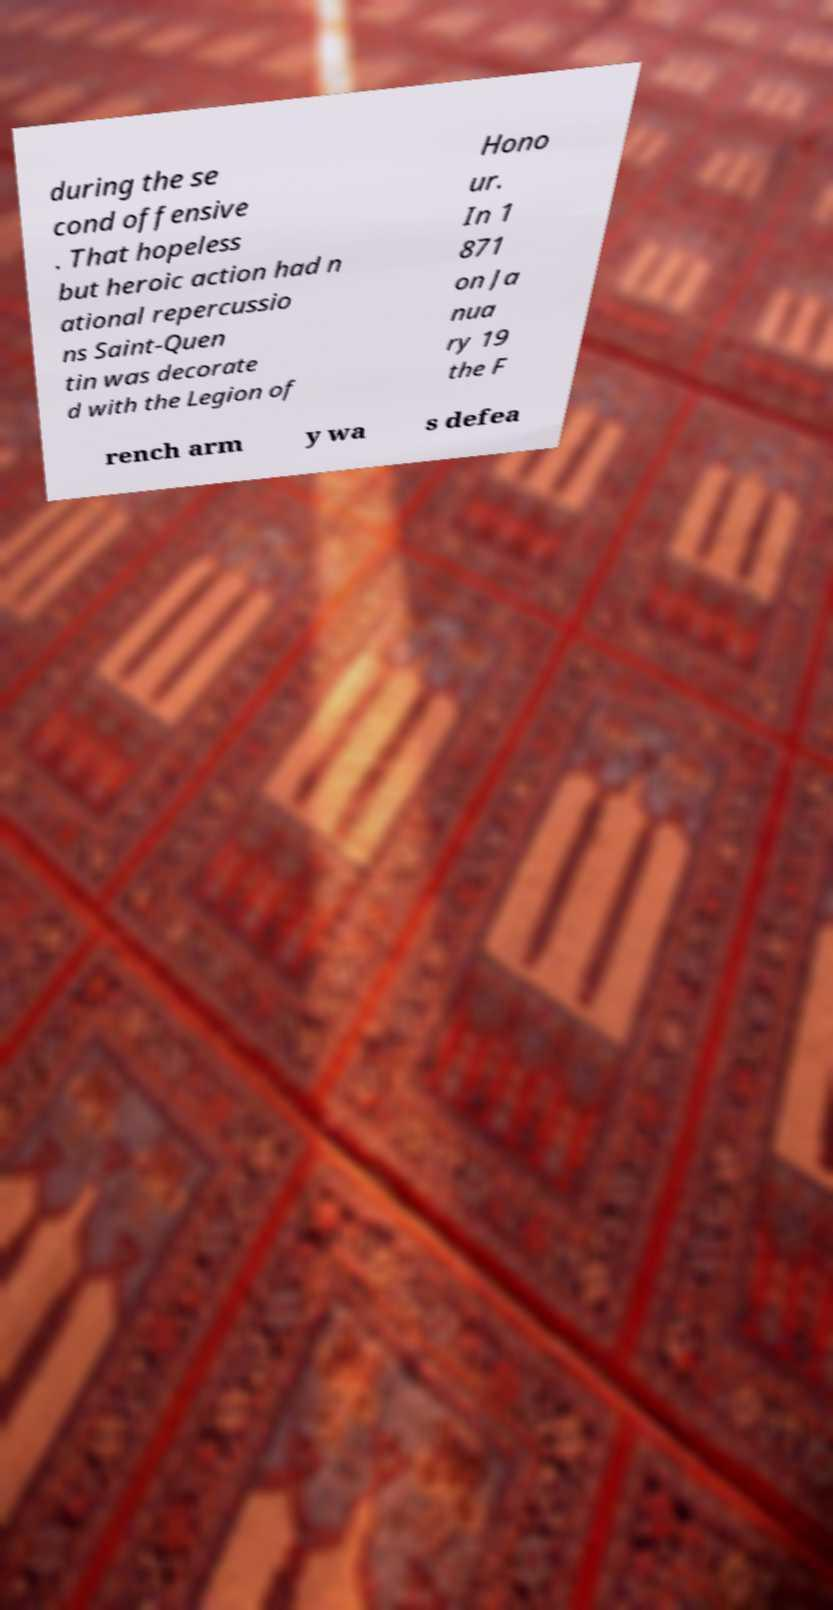Could you assist in decoding the text presented in this image and type it out clearly? during the se cond offensive . That hopeless but heroic action had n ational repercussio ns Saint-Quen tin was decorate d with the Legion of Hono ur. In 1 871 on Ja nua ry 19 the F rench arm y wa s defea 